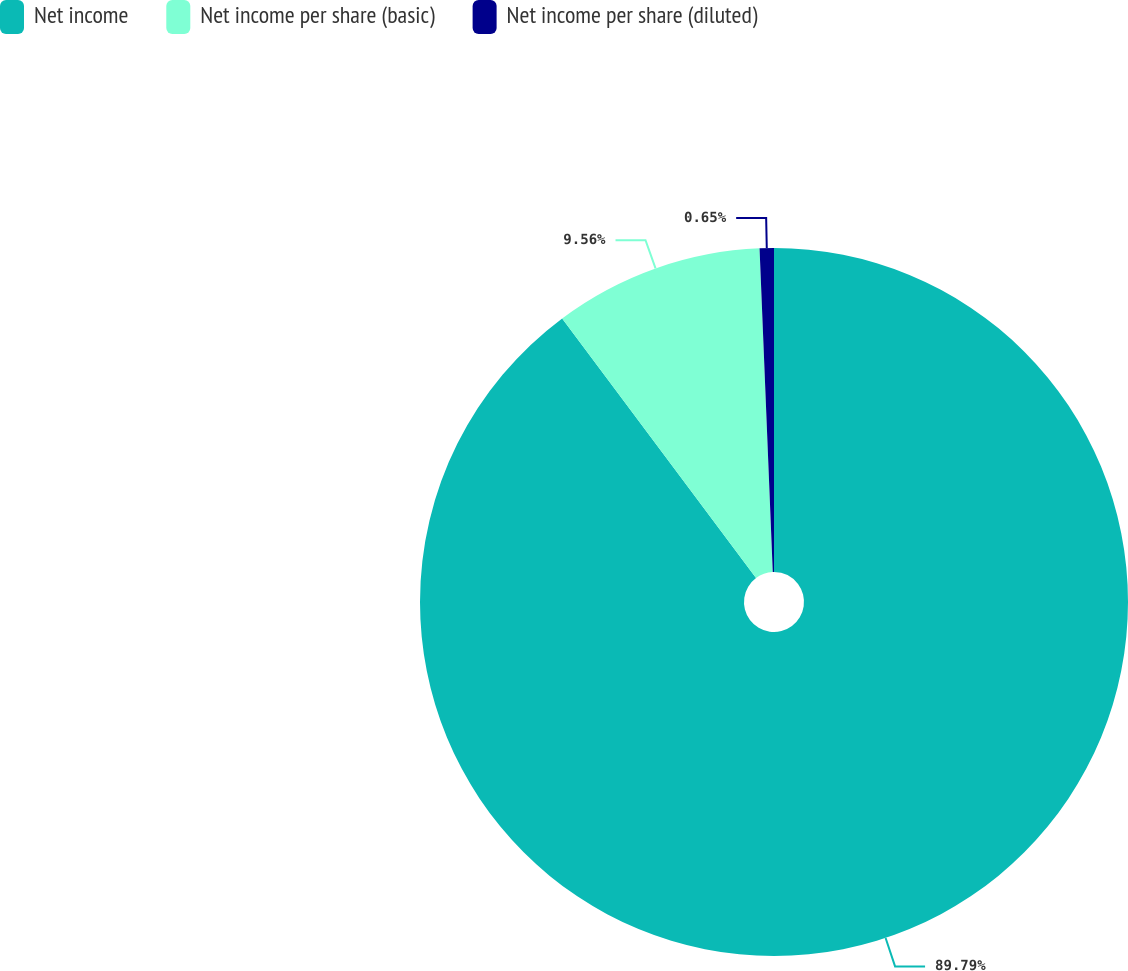Convert chart. <chart><loc_0><loc_0><loc_500><loc_500><pie_chart><fcel>Net income<fcel>Net income per share (basic)<fcel>Net income per share (diluted)<nl><fcel>89.79%<fcel>9.56%<fcel>0.65%<nl></chart> 